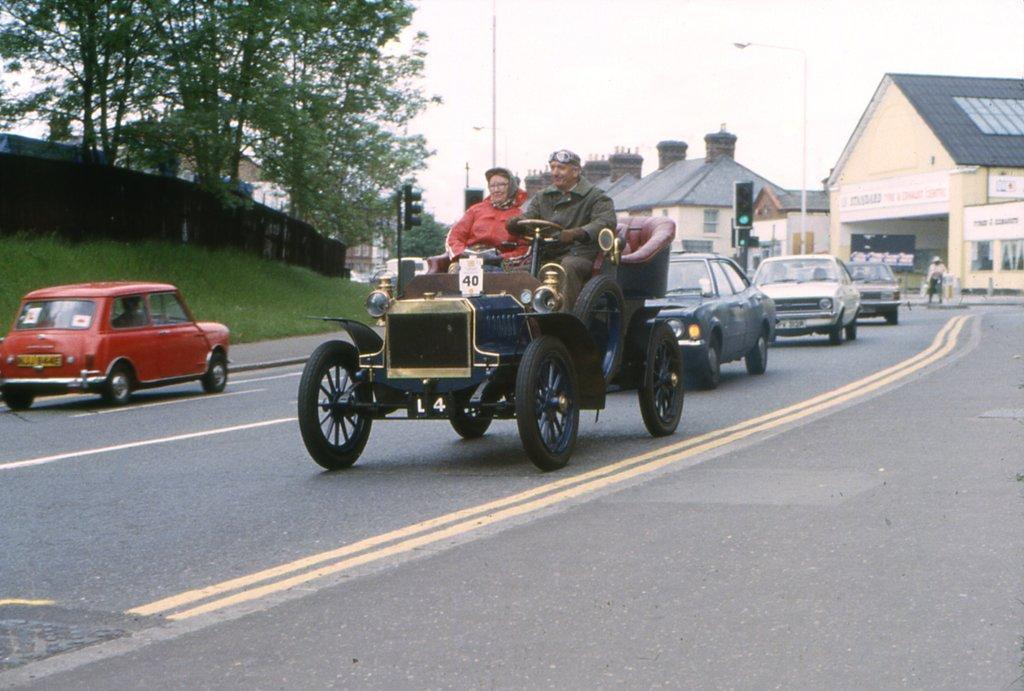Can you describe this image briefly? This picture is clicked outside. In the center we can see the group of vehicles and we can see the group of persons. In the background we can see the sky, houses, poles, lights, traffic light, trees and the green grass and some other objects. 